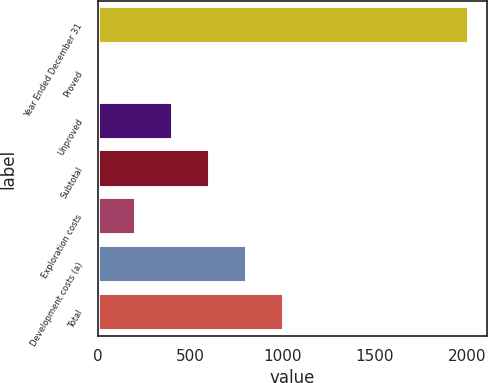<chart> <loc_0><loc_0><loc_500><loc_500><bar_chart><fcel>Year Ended December 31<fcel>Proved<fcel>Unproved<fcel>Subtotal<fcel>Exploration costs<fcel>Development costs (a)<fcel>Total<nl><fcel>2008<fcel>8<fcel>408<fcel>608<fcel>208<fcel>808<fcel>1008<nl></chart> 